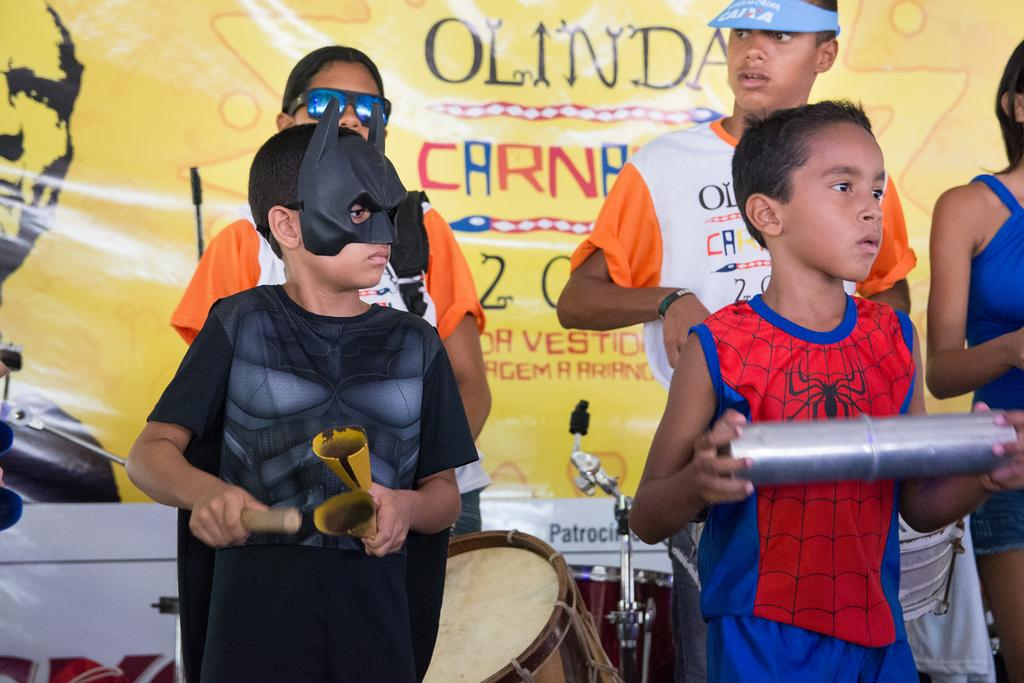What is the main subject of the image? The main subject of the image is the children in the center of the image. What object is located at the bottom side of the image? There is a drum at the bottom side of the image. What can be seen in the background of the image? There is a flex in the background of the image. What type of airplane is visible in the image? There is no airplane present in the image. Can you tell me how many chess pieces are on the flex in the background? There is no chess set visible in the image, so it is not possible to determine the number of chess pieces. What type of magic trick is being performed by the children in the image? There is no indication of a magic trick being performed in the image; the children are simply present in the center of the image. 